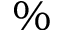Convert formula to latex. <formula><loc_0><loc_0><loc_500><loc_500>\%</formula> 